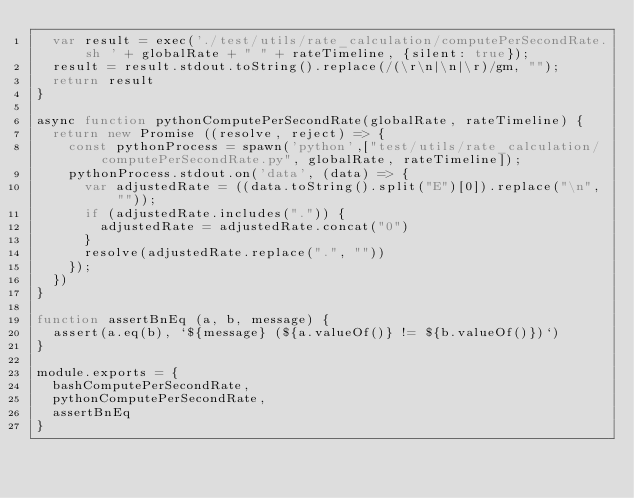Convert code to text. <code><loc_0><loc_0><loc_500><loc_500><_JavaScript_>  var result = exec('./test/utils/rate_calculation/computePerSecondRate.sh ' + globalRate + " " + rateTimeline, {silent: true});
  result = result.stdout.toString().replace(/(\r\n|\n|\r)/gm, "");
  return result
}

async function pythonComputePerSecondRate(globalRate, rateTimeline) {
  return new Promise ((resolve, reject) => {
    const pythonProcess = spawn('python',["test/utils/rate_calculation/computePerSecondRate.py", globalRate, rateTimeline]);
    pythonProcess.stdout.on('data', (data) => {
      var adjustedRate = ((data.toString().split("E")[0]).replace("\n", ""));
      if (adjustedRate.includes(".")) {
        adjustedRate = adjustedRate.concat("0")
      }
      resolve(adjustedRate.replace(".", ""))
    });
  })
}

function assertBnEq (a, b, message) {
  assert(a.eq(b), `${message} (${a.valueOf()} != ${b.valueOf()})`)
}

module.exports = {
  bashComputePerSecondRate,
  pythonComputePerSecondRate,
  assertBnEq
}
</code> 